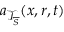<formula> <loc_0><loc_0><loc_500><loc_500>a _ { \mathcal { T } _ { \overline { S } } } ( x , r , t )</formula> 